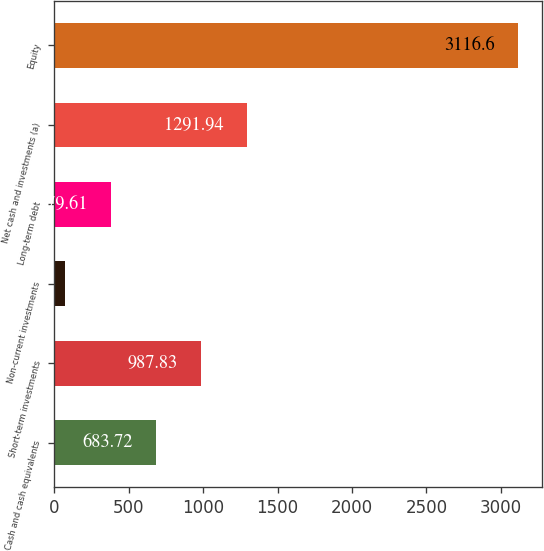<chart> <loc_0><loc_0><loc_500><loc_500><bar_chart><fcel>Cash and cash equivalents<fcel>Short-term investments<fcel>Non-current investments<fcel>Long-term debt<fcel>Net cash and investments (a)<fcel>Equity<nl><fcel>683.72<fcel>987.83<fcel>75.5<fcel>379.61<fcel>1291.94<fcel>3116.6<nl></chart> 